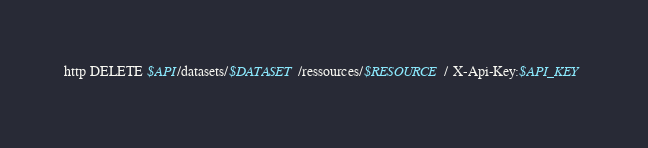Convert code to text. <code><loc_0><loc_0><loc_500><loc_500><_Bash_>http DELETE $API/datasets/$DATASET/ressources/$RESOURCE/ X-Api-Key:$API_KEY
</code> 